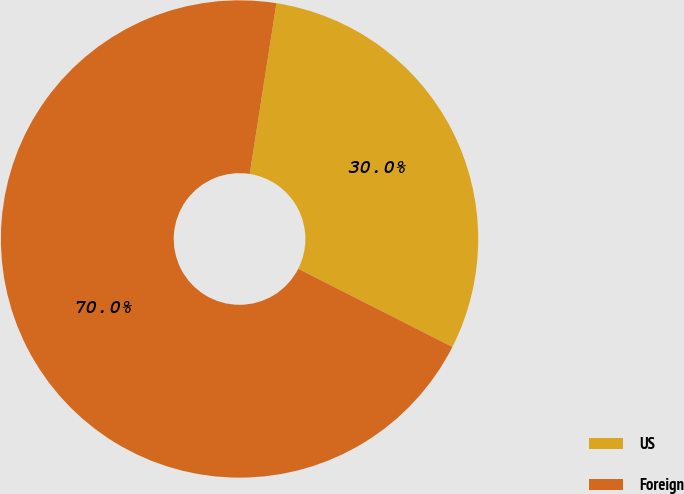Convert chart. <chart><loc_0><loc_0><loc_500><loc_500><pie_chart><fcel>US<fcel>Foreign<nl><fcel>30.0%<fcel>70.0%<nl></chart> 